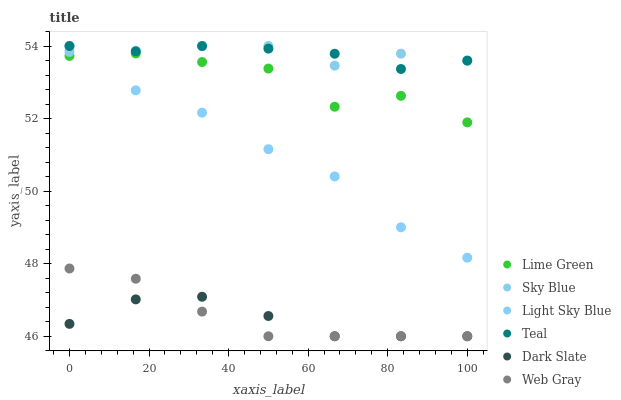Does Dark Slate have the minimum area under the curve?
Answer yes or no. Yes. Does Sky Blue have the maximum area under the curve?
Answer yes or no. Yes. Does Light Sky Blue have the minimum area under the curve?
Answer yes or no. No. Does Light Sky Blue have the maximum area under the curve?
Answer yes or no. No. Is Teal the smoothest?
Answer yes or no. Yes. Is Lime Green the roughest?
Answer yes or no. Yes. Is Dark Slate the smoothest?
Answer yes or no. No. Is Dark Slate the roughest?
Answer yes or no. No. Does Web Gray have the lowest value?
Answer yes or no. Yes. Does Light Sky Blue have the lowest value?
Answer yes or no. No. Does Sky Blue have the highest value?
Answer yes or no. Yes. Does Dark Slate have the highest value?
Answer yes or no. No. Is Dark Slate less than Lime Green?
Answer yes or no. Yes. Is Sky Blue greater than Lime Green?
Answer yes or no. Yes. Does Teal intersect Sky Blue?
Answer yes or no. Yes. Is Teal less than Sky Blue?
Answer yes or no. No. Is Teal greater than Sky Blue?
Answer yes or no. No. Does Dark Slate intersect Lime Green?
Answer yes or no. No. 